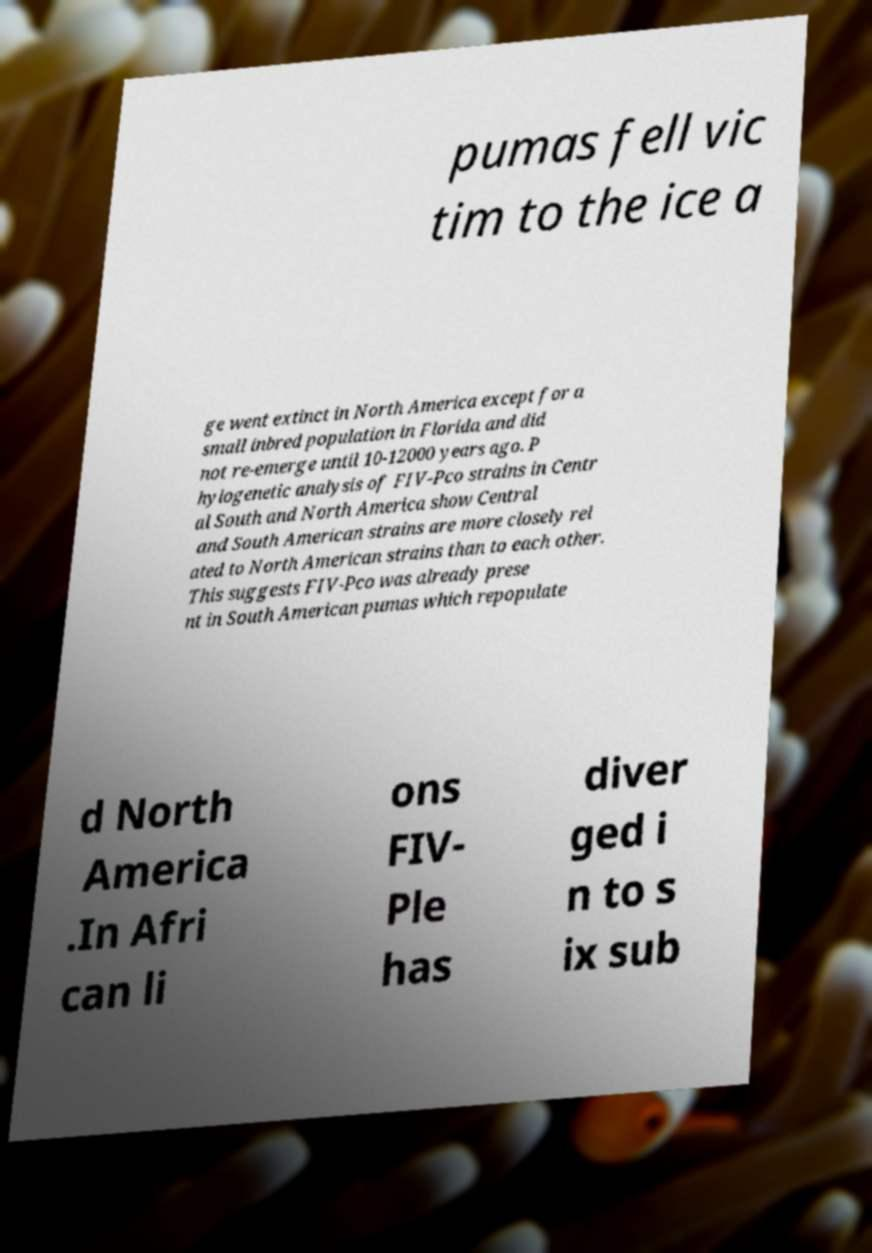Can you accurately transcribe the text from the provided image for me? pumas fell vic tim to the ice a ge went extinct in North America except for a small inbred population in Florida and did not re-emerge until 10-12000 years ago. P hylogenetic analysis of FIV-Pco strains in Centr al South and North America show Central and South American strains are more closely rel ated to North American strains than to each other. This suggests FIV-Pco was already prese nt in South American pumas which repopulate d North America .In Afri can li ons FIV- Ple has diver ged i n to s ix sub 